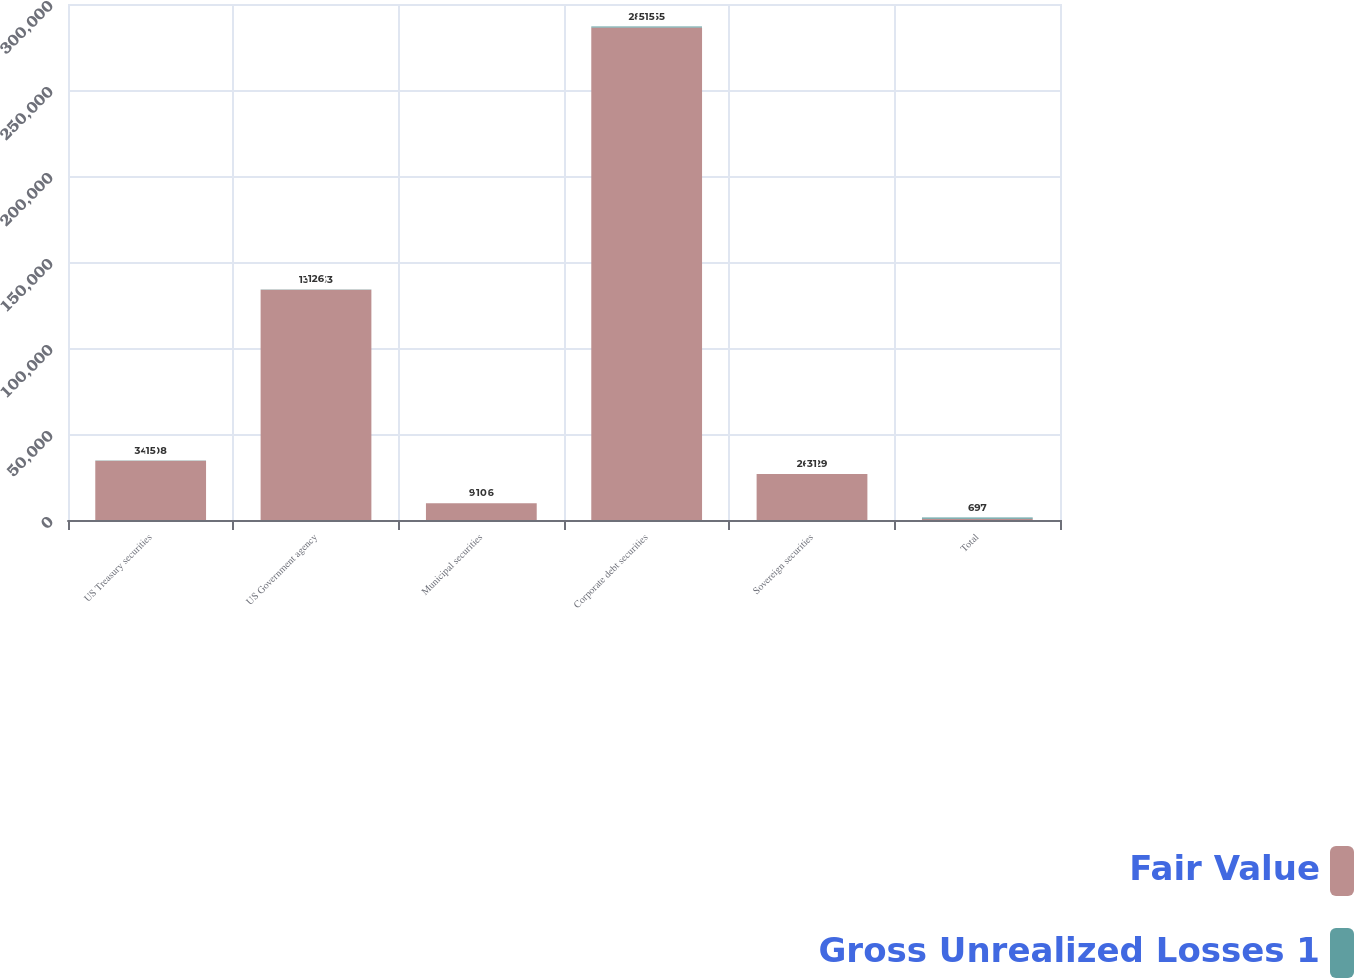<chart> <loc_0><loc_0><loc_500><loc_500><stacked_bar_chart><ecel><fcel>US Treasury securities<fcel>US Government agency<fcel>Municipal securities<fcel>Corporate debt securities<fcel>Sovereign securities<fcel>Total<nl><fcel>Fair Value<fcel>34508<fcel>133933<fcel>9776<fcel>286355<fcel>26729<fcel>697<nl><fcel>Gross Unrealized Losses 1<fcel>15<fcel>126<fcel>10<fcel>515<fcel>31<fcel>697<nl></chart> 